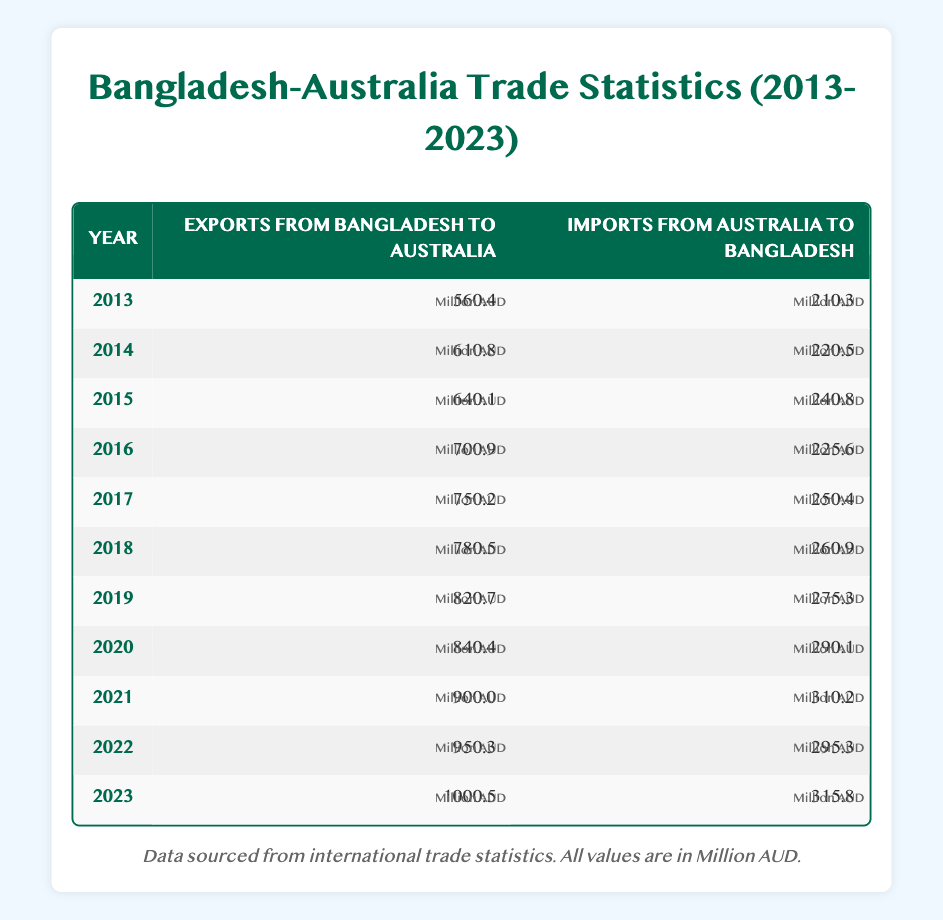What were the exports from Bangladesh to Australia in 2020? In the year 2020, the exports from Bangladesh to Australia are listed in the table as 840.4 million AUD.
Answer: 840.4 million AUD What was the import value from Australia to Bangladesh in 2015? Referring to the table for the year 2015, the imports from Australia to Bangladesh are recorded as 240.8 million AUD.
Answer: 240.8 million AUD Which year showed the highest export value from Bangladesh to Australia? By examining the export values for all the years in the table, 2023 shows the highest export value at 1000.5 million AUD.
Answer: 2023 Is the import value from Australia to Bangladesh greater in 2021 than in 2019? In the table, the import value in 2021 is 310.2 million AUD and in 2019 it is 275.3 million AUD. Since 310.2 is greater than 275.3, the statement is true.
Answer: Yes What is the total export value from Bangladesh to Australia over the years from 2013 to 2022? The export values from 2013 to 2022 are: 560.4, 610.8, 640.1, 700.9, 750.2, 780.5, 820.7, 840.4, 900.0, and 950.3 million AUD. Summing these gives 5612.9 million AUD.
Answer: 5612.9 million AUD What is the average import value from Australia to Bangladesh for the years 2017 to 2022? The import values for the years 2017 to 2022 are 250.4, 260.9, 275.3, 290.1, 310.2, and 295.3 million AUD. The sum is 1682.2 million AUD, and dividing this by 6 gives an average of 280.37 million AUD.
Answer: 280.37 million AUD In which year was the import value from Australia to Bangladesh less than 220 million AUD? The table shows that in 2013 the import value was 210.3 million AUD, which is less than 220 million AUD. Other years either equal or exceed 220 million AUD.
Answer: 2013 What is the difference in export values from Bangladesh to Australia between 2015 and 2021? The export values are 640.1 million AUD for 2015 and 900.0 million AUD for 2021. The difference is 900.0 - 640.1 = 259.9 million AUD.
Answer: 259.9 million AUD 